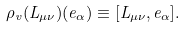Convert formula to latex. <formula><loc_0><loc_0><loc_500><loc_500>\rho _ { v } ( L _ { \mu \nu } ) ( e _ { \alpha } ) \equiv [ L _ { \mu \nu } , e _ { \alpha } ] .</formula> 